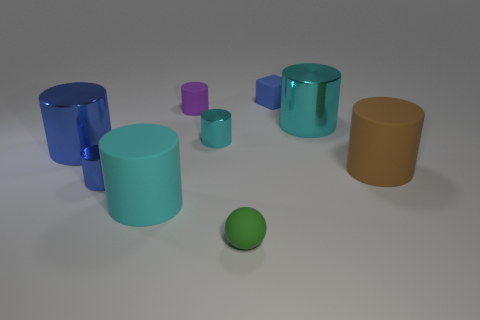Can you describe the size and color relations among the objects? Certainly! In the image, we can observe a collection of cylindrical and cuboid shapes with varying sizes. The largest appears to be a blue cylinder, while the smallest is a purple cuboid. The colors range from blue and teal to purple and orange, each possessing a glossy finish indicating they might be made of plastic or a similar material. There isn't a uniform progression of sizes or colors; they seem quite randomly assorted. 